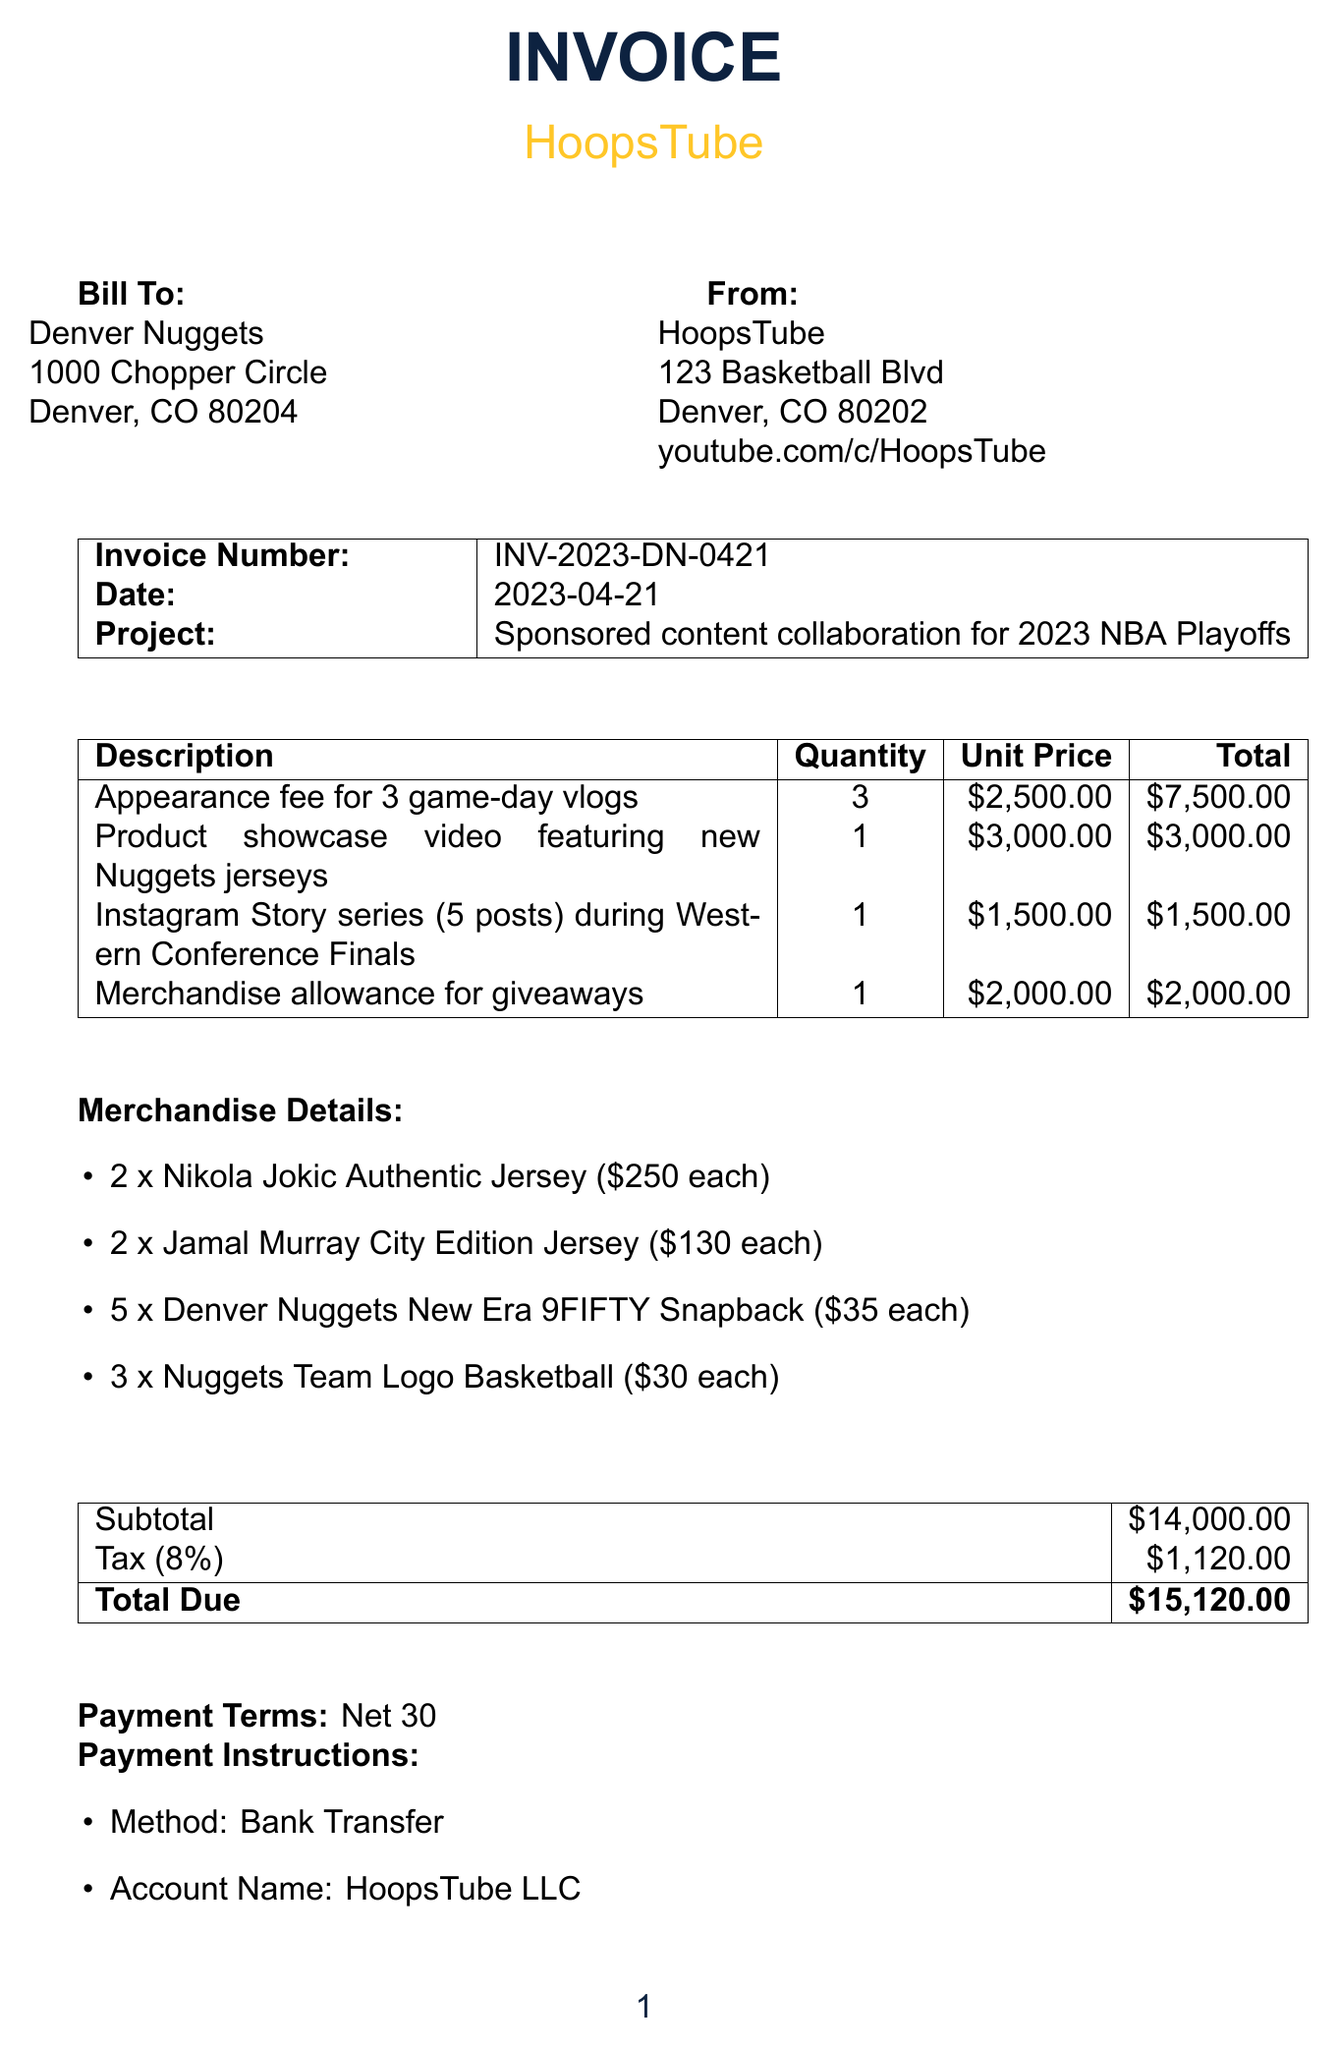what is the invoice number? The invoice number is explicitly stated in the document, which is INV-2023-DN-0421.
Answer: INV-2023-DN-0421 what is the date of the invoice? The date of the invoice is mentioned clearly, which is 2023-04-21.
Answer: 2023-04-21 who is the client? The client is identified in the document as the Denver Nuggets.
Answer: Denver Nuggets how many game-day vlogs were included in the appearance fee? The document states an appearance fee for 3 game-day vlogs.
Answer: 3 what is the total due amount? The total due amount is the final figure mentioned at the end of the document, which is $15,120.
Answer: $15,120 how much is the merchandise allowance for giveaways? The merchandise allowance is specified as $2,000 in the line items.
Answer: $2,000 what is the tax rate applied to the subtotal? The tax rate shown in the document is 8%.
Answer: 8% how many jerseys were ordered for Nikola Jokic? The merchandise details indicate that 2 Nikola Jokic Authentic Jerseys were ordered.
Answer: 2 what payment method is specified for payment? The specified payment method in the document is Bank Transfer.
Answer: Bank Transfer 